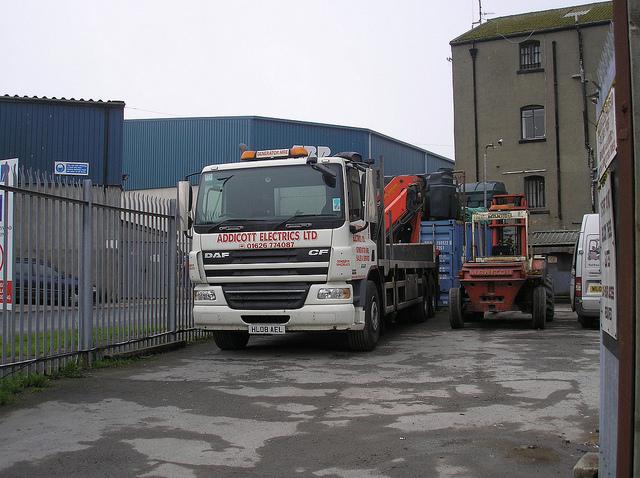What company owns the truck?
Concise answer only. Addicott electrics. Is there a gate?
Write a very short answer. Yes. How many vehicles are in this photo?
Be succinct. 4. Are people sitting in the truck?
Write a very short answer. No. 